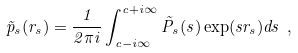<formula> <loc_0><loc_0><loc_500><loc_500>\tilde { p } _ { s } ( r _ { s } ) = \frac { 1 } { 2 \pi i } \int _ { c - i \infty } ^ { c + i \infty } \tilde { P } _ { s } ( s ) \exp ( s r _ { s } ) d s \ ,</formula> 